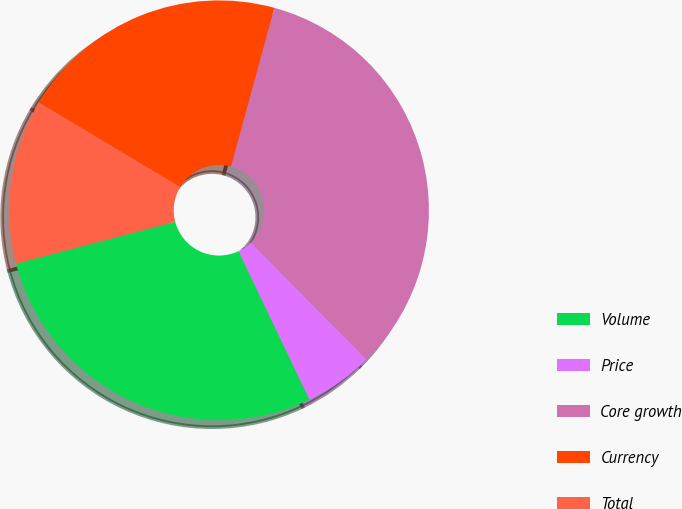Convert chart. <chart><loc_0><loc_0><loc_500><loc_500><pie_chart><fcel>Volume<fcel>Price<fcel>Core growth<fcel>Currency<fcel>Total<nl><fcel>28.0%<fcel>5.33%<fcel>33.33%<fcel>20.67%<fcel>12.67%<nl></chart> 